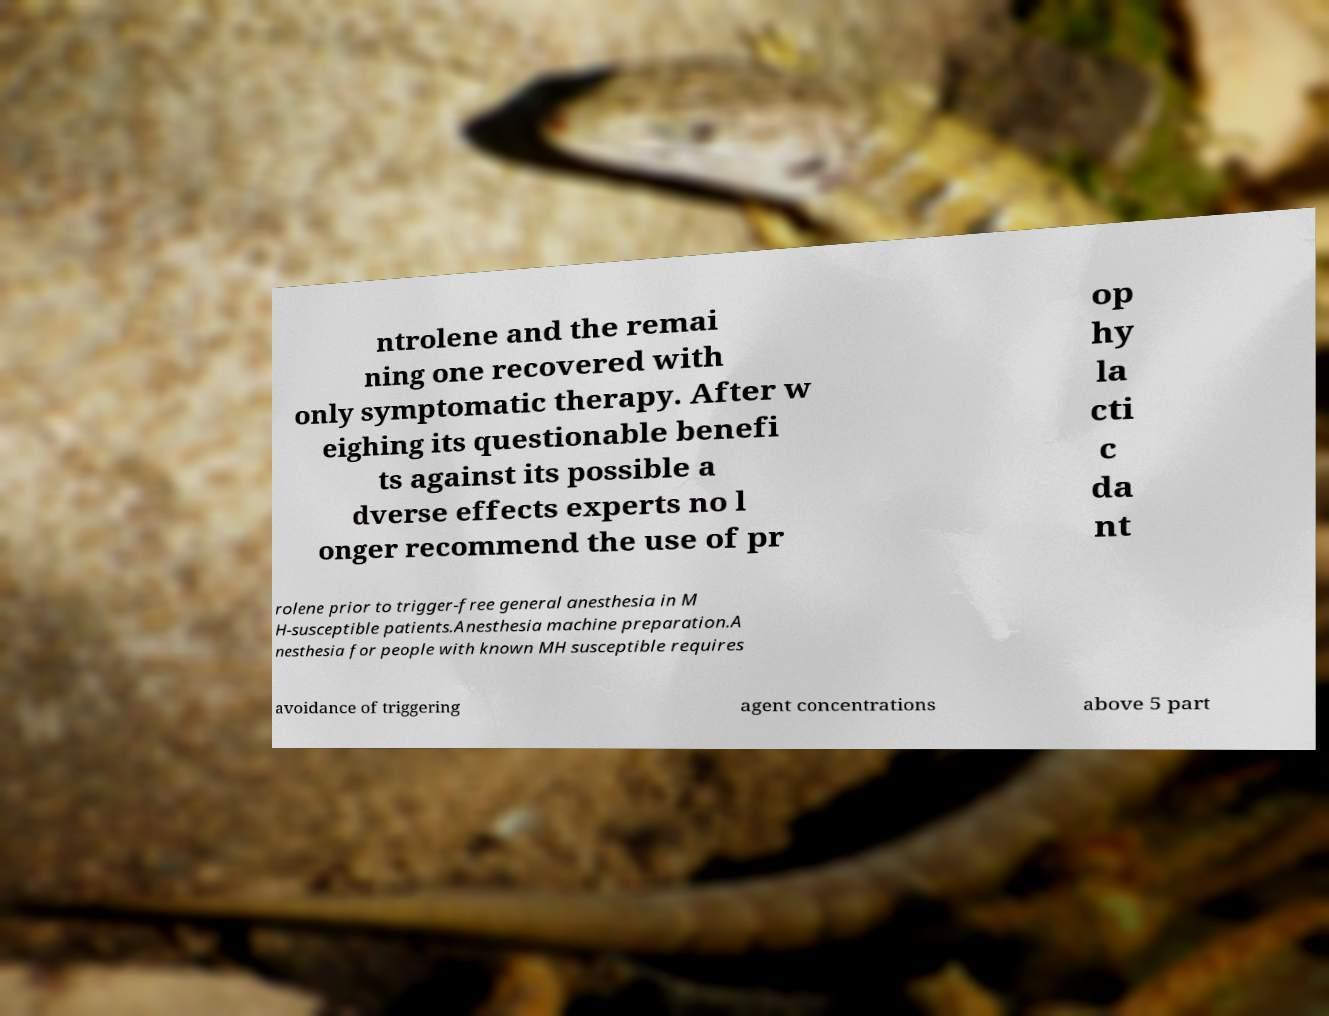Can you accurately transcribe the text from the provided image for me? ntrolene and the remai ning one recovered with only symptomatic therapy. After w eighing its questionable benefi ts against its possible a dverse effects experts no l onger recommend the use of pr op hy la cti c da nt rolene prior to trigger-free general anesthesia in M H-susceptible patients.Anesthesia machine preparation.A nesthesia for people with known MH susceptible requires avoidance of triggering agent concentrations above 5 part 